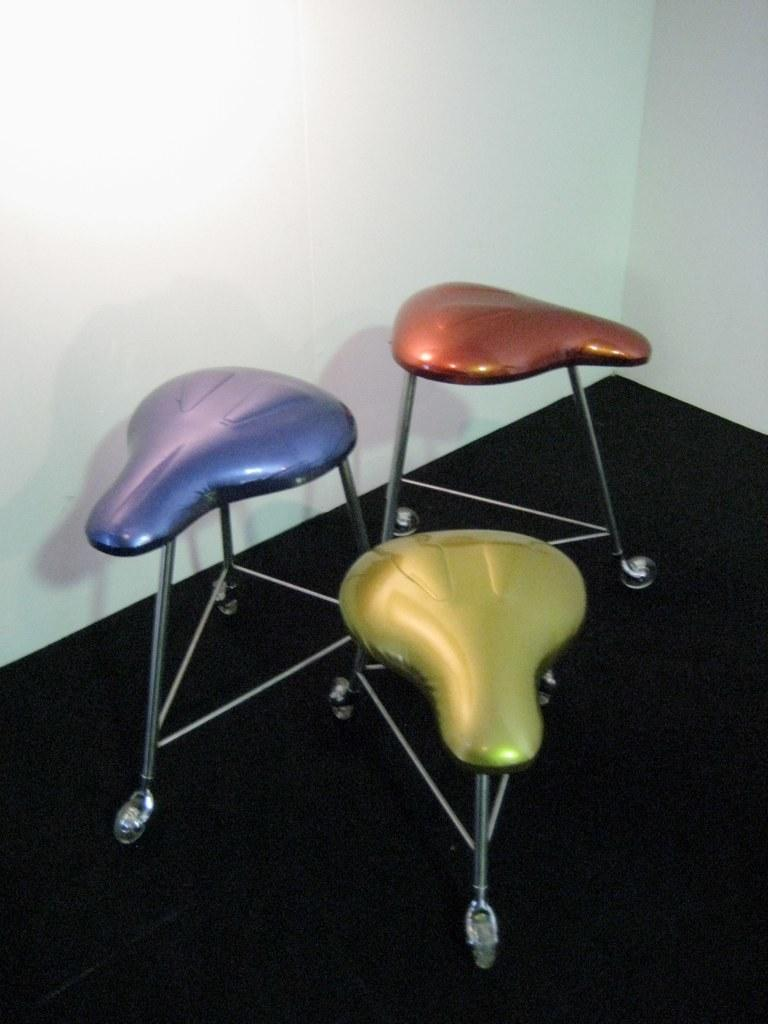What type of chairs are in the image? There are three chairs with wheels in the image. What is the color of the floor in the image? The floor is black in color. What can be seen on the sides or behind the chairs in the image? There is a wall visible in the image. What type of rhythm can be heard from the committee meeting at the seashore in the image? There is no committee meeting or seashore present in the image; it only features three chairs with wheels and a wall. 